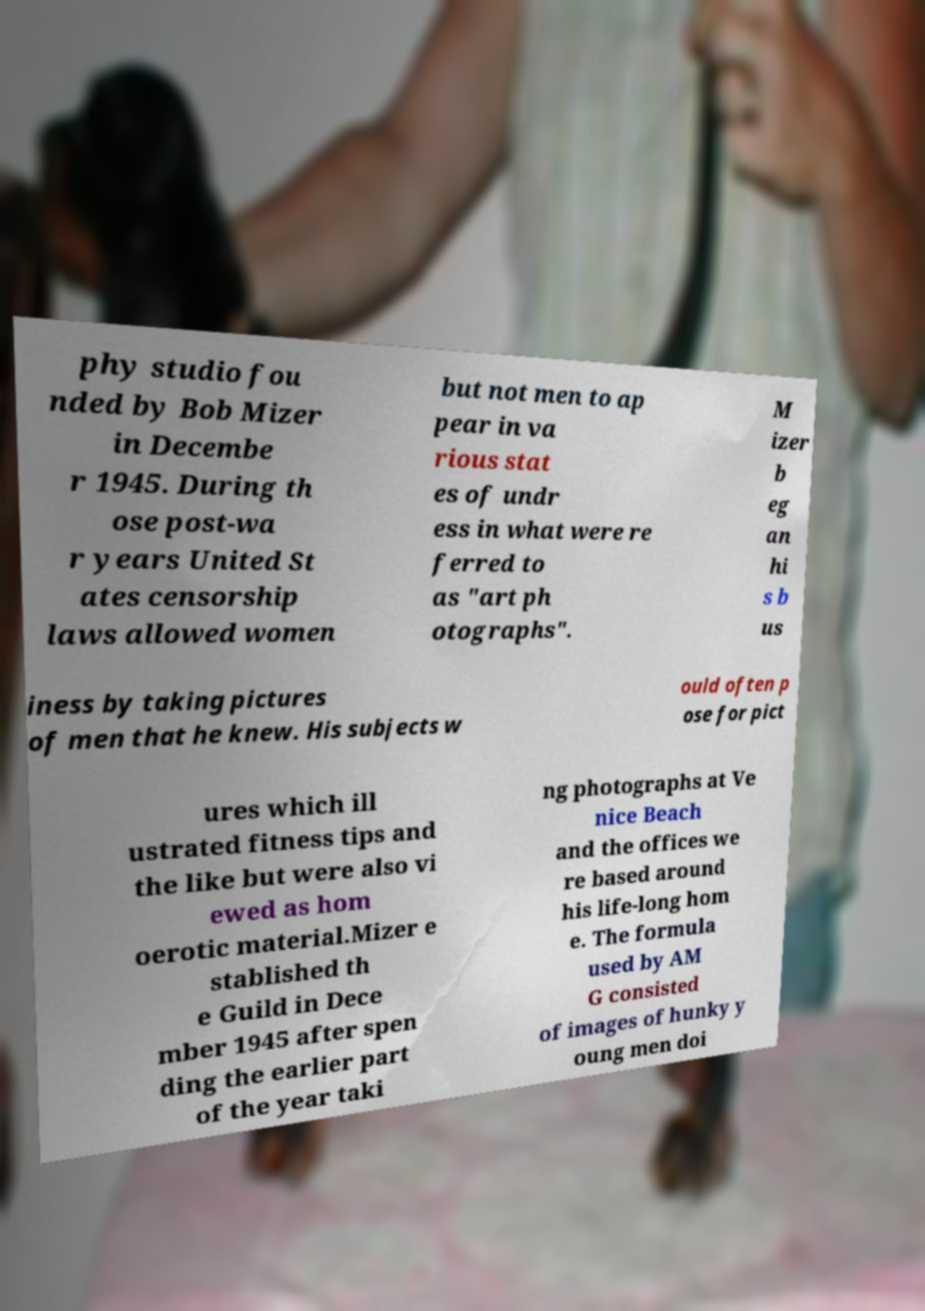Please identify and transcribe the text found in this image. phy studio fou nded by Bob Mizer in Decembe r 1945. During th ose post-wa r years United St ates censorship laws allowed women but not men to ap pear in va rious stat es of undr ess in what were re ferred to as "art ph otographs". M izer b eg an hi s b us iness by taking pictures of men that he knew. His subjects w ould often p ose for pict ures which ill ustrated fitness tips and the like but were also vi ewed as hom oerotic material.Mizer e stablished th e Guild in Dece mber 1945 after spen ding the earlier part of the year taki ng photographs at Ve nice Beach and the offices we re based around his life-long hom e. The formula used by AM G consisted of images of hunky y oung men doi 